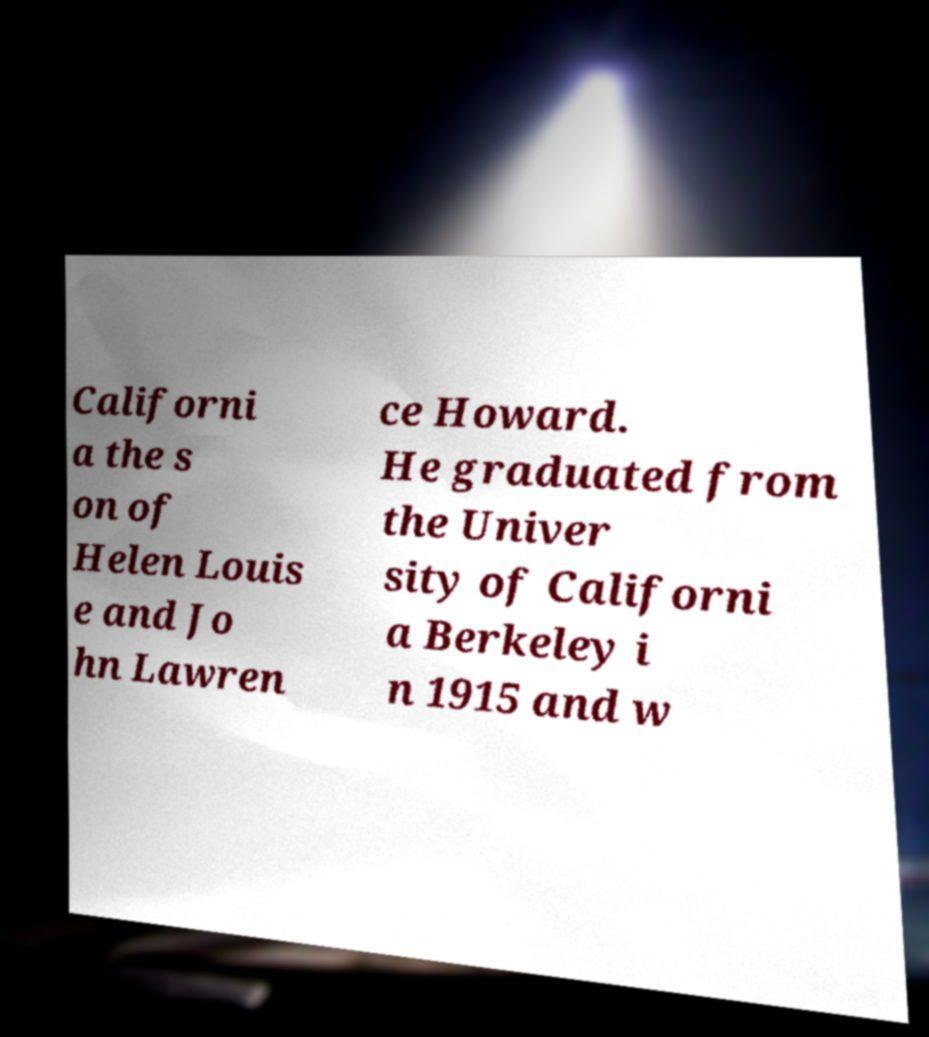For documentation purposes, I need the text within this image transcribed. Could you provide that? Californi a the s on of Helen Louis e and Jo hn Lawren ce Howard. He graduated from the Univer sity of Californi a Berkeley i n 1915 and w 